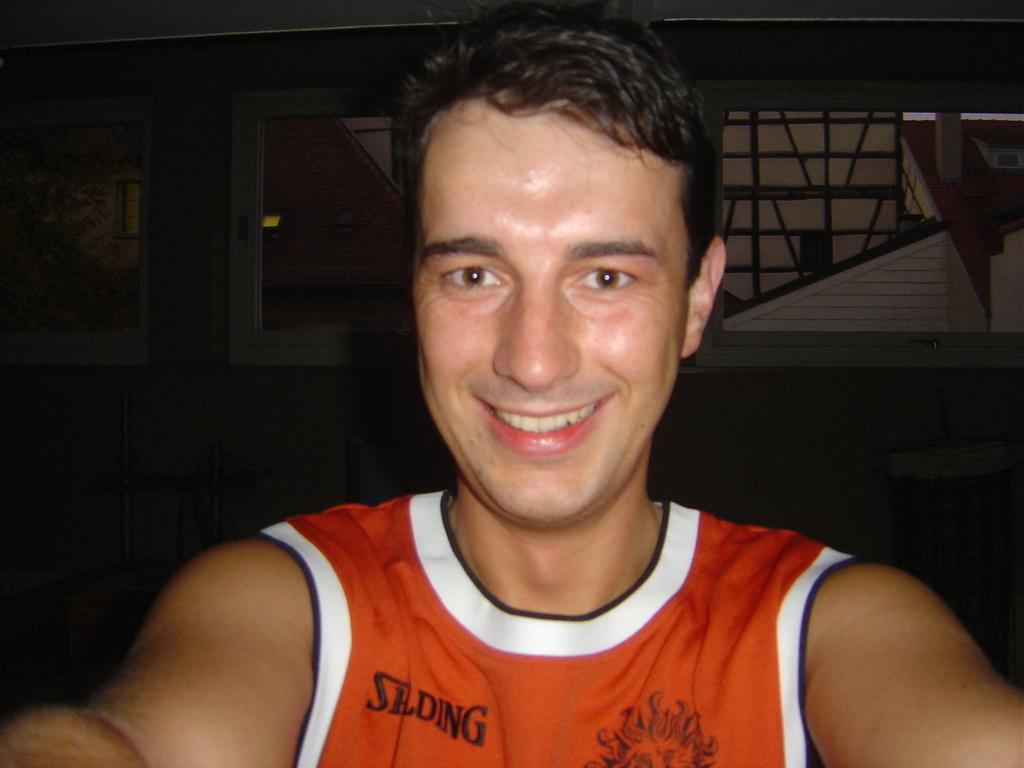Provide a one-sentence caption for the provided image. A man is wearing a orange shirt with the the letters SLDWG on his right of his shirt. 